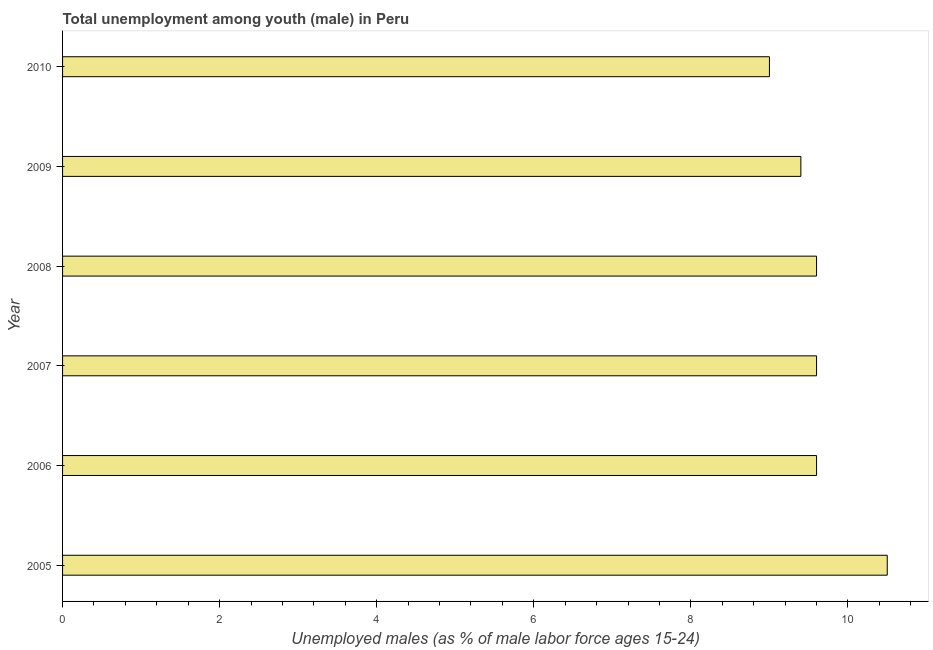Does the graph contain any zero values?
Your answer should be very brief. No. Does the graph contain grids?
Offer a very short reply. No. What is the title of the graph?
Provide a short and direct response. Total unemployment among youth (male) in Peru. What is the label or title of the X-axis?
Keep it short and to the point. Unemployed males (as % of male labor force ages 15-24). What is the label or title of the Y-axis?
Your answer should be very brief. Year. What is the unemployed male youth population in 2010?
Offer a terse response. 9. Across all years, what is the minimum unemployed male youth population?
Offer a very short reply. 9. In which year was the unemployed male youth population maximum?
Make the answer very short. 2005. In which year was the unemployed male youth population minimum?
Your response must be concise. 2010. What is the sum of the unemployed male youth population?
Ensure brevity in your answer.  57.7. What is the average unemployed male youth population per year?
Your answer should be compact. 9.62. What is the median unemployed male youth population?
Ensure brevity in your answer.  9.6. In how many years, is the unemployed male youth population greater than 2.8 %?
Ensure brevity in your answer.  6. Do a majority of the years between 2008 and 2010 (inclusive) have unemployed male youth population greater than 6.8 %?
Provide a succinct answer. Yes. What is the difference between the highest and the second highest unemployed male youth population?
Your response must be concise. 0.9. Is the sum of the unemployed male youth population in 2007 and 2008 greater than the maximum unemployed male youth population across all years?
Your answer should be very brief. Yes. How many bars are there?
Keep it short and to the point. 6. Are all the bars in the graph horizontal?
Your response must be concise. Yes. How many years are there in the graph?
Your answer should be very brief. 6. What is the Unemployed males (as % of male labor force ages 15-24) of 2005?
Offer a terse response. 10.5. What is the Unemployed males (as % of male labor force ages 15-24) of 2006?
Make the answer very short. 9.6. What is the Unemployed males (as % of male labor force ages 15-24) of 2007?
Keep it short and to the point. 9.6. What is the Unemployed males (as % of male labor force ages 15-24) of 2008?
Your response must be concise. 9.6. What is the Unemployed males (as % of male labor force ages 15-24) in 2009?
Your answer should be compact. 9.4. What is the Unemployed males (as % of male labor force ages 15-24) in 2010?
Offer a very short reply. 9. What is the difference between the Unemployed males (as % of male labor force ages 15-24) in 2005 and 2008?
Ensure brevity in your answer.  0.9. What is the difference between the Unemployed males (as % of male labor force ages 15-24) in 2005 and 2009?
Offer a terse response. 1.1. What is the difference between the Unemployed males (as % of male labor force ages 15-24) in 2005 and 2010?
Offer a terse response. 1.5. What is the difference between the Unemployed males (as % of male labor force ages 15-24) in 2006 and 2008?
Offer a terse response. 0. What is the difference between the Unemployed males (as % of male labor force ages 15-24) in 2006 and 2010?
Offer a terse response. 0.6. What is the difference between the Unemployed males (as % of male labor force ages 15-24) in 2007 and 2008?
Provide a succinct answer. 0. What is the difference between the Unemployed males (as % of male labor force ages 15-24) in 2009 and 2010?
Give a very brief answer. 0.4. What is the ratio of the Unemployed males (as % of male labor force ages 15-24) in 2005 to that in 2006?
Offer a very short reply. 1.09. What is the ratio of the Unemployed males (as % of male labor force ages 15-24) in 2005 to that in 2007?
Keep it short and to the point. 1.09. What is the ratio of the Unemployed males (as % of male labor force ages 15-24) in 2005 to that in 2008?
Your answer should be compact. 1.09. What is the ratio of the Unemployed males (as % of male labor force ages 15-24) in 2005 to that in 2009?
Provide a short and direct response. 1.12. What is the ratio of the Unemployed males (as % of male labor force ages 15-24) in 2005 to that in 2010?
Offer a very short reply. 1.17. What is the ratio of the Unemployed males (as % of male labor force ages 15-24) in 2006 to that in 2007?
Keep it short and to the point. 1. What is the ratio of the Unemployed males (as % of male labor force ages 15-24) in 2006 to that in 2009?
Ensure brevity in your answer.  1.02. What is the ratio of the Unemployed males (as % of male labor force ages 15-24) in 2006 to that in 2010?
Offer a terse response. 1.07. What is the ratio of the Unemployed males (as % of male labor force ages 15-24) in 2007 to that in 2009?
Ensure brevity in your answer.  1.02. What is the ratio of the Unemployed males (as % of male labor force ages 15-24) in 2007 to that in 2010?
Your answer should be very brief. 1.07. What is the ratio of the Unemployed males (as % of male labor force ages 15-24) in 2008 to that in 2010?
Ensure brevity in your answer.  1.07. What is the ratio of the Unemployed males (as % of male labor force ages 15-24) in 2009 to that in 2010?
Your answer should be very brief. 1.04. 